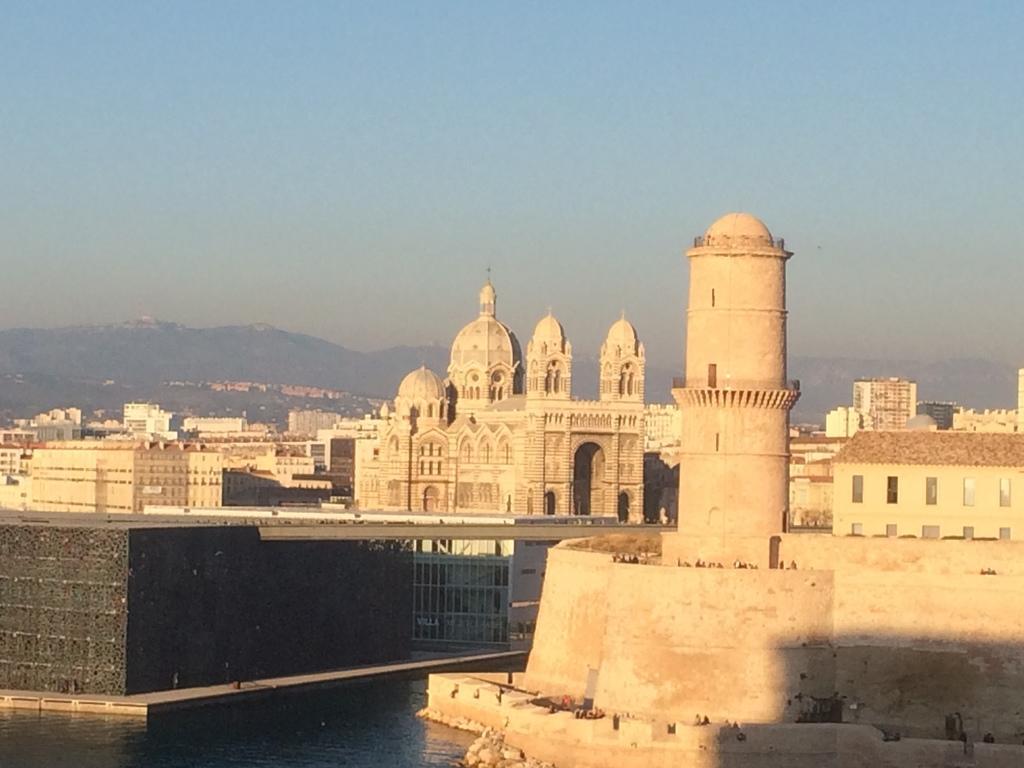How would you summarize this image in a sentence or two? In this image there are buildings, water , and in the background there are hills,sky. 